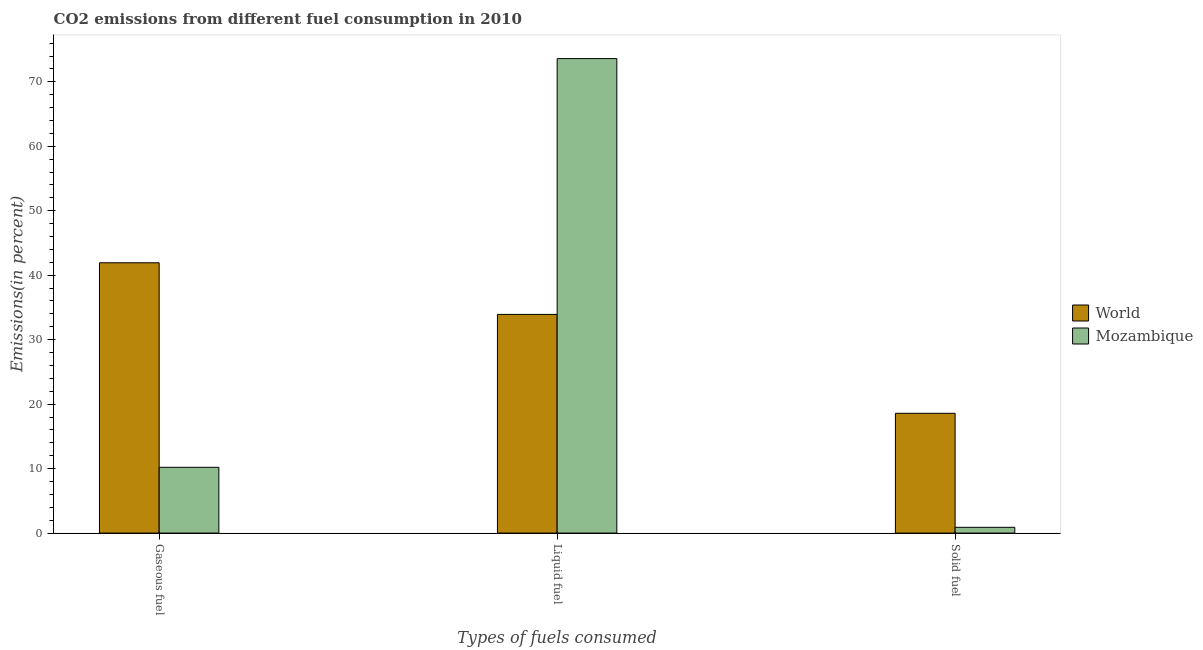Are the number of bars on each tick of the X-axis equal?
Give a very brief answer. Yes. How many bars are there on the 2nd tick from the right?
Keep it short and to the point. 2. What is the label of the 1st group of bars from the left?
Give a very brief answer. Gaseous fuel. What is the percentage of liquid fuel emission in Mozambique?
Keep it short and to the point. 73.6. Across all countries, what is the maximum percentage of liquid fuel emission?
Offer a very short reply. 73.6. Across all countries, what is the minimum percentage of liquid fuel emission?
Offer a very short reply. 33.92. What is the total percentage of gaseous fuel emission in the graph?
Offer a terse response. 52.13. What is the difference between the percentage of gaseous fuel emission in Mozambique and that in World?
Offer a terse response. -31.72. What is the difference between the percentage of solid fuel emission in Mozambique and the percentage of gaseous fuel emission in World?
Ensure brevity in your answer.  -41.03. What is the average percentage of solid fuel emission per country?
Provide a short and direct response. 9.74. What is the difference between the percentage of gaseous fuel emission and percentage of solid fuel emission in World?
Your response must be concise. 23.35. What is the ratio of the percentage of gaseous fuel emission in Mozambique to that in World?
Offer a terse response. 0.24. Is the percentage of gaseous fuel emission in Mozambique less than that in World?
Your answer should be very brief. Yes. What is the difference between the highest and the second highest percentage of solid fuel emission?
Provide a succinct answer. 17.68. What is the difference between the highest and the lowest percentage of liquid fuel emission?
Give a very brief answer. 39.68. In how many countries, is the percentage of gaseous fuel emission greater than the average percentage of gaseous fuel emission taken over all countries?
Ensure brevity in your answer.  1. What does the 1st bar from the right in Gaseous fuel represents?
Make the answer very short. Mozambique. Is it the case that in every country, the sum of the percentage of gaseous fuel emission and percentage of liquid fuel emission is greater than the percentage of solid fuel emission?
Offer a very short reply. Yes. How many bars are there?
Ensure brevity in your answer.  6. Are all the bars in the graph horizontal?
Give a very brief answer. No. How many countries are there in the graph?
Make the answer very short. 2. What is the difference between two consecutive major ticks on the Y-axis?
Your response must be concise. 10. How are the legend labels stacked?
Give a very brief answer. Vertical. What is the title of the graph?
Keep it short and to the point. CO2 emissions from different fuel consumption in 2010. What is the label or title of the X-axis?
Offer a terse response. Types of fuels consumed. What is the label or title of the Y-axis?
Provide a succinct answer. Emissions(in percent). What is the Emissions(in percent) in World in Gaseous fuel?
Provide a succinct answer. 41.93. What is the Emissions(in percent) of Mozambique in Gaseous fuel?
Your response must be concise. 10.2. What is the Emissions(in percent) of World in Liquid fuel?
Provide a succinct answer. 33.92. What is the Emissions(in percent) in Mozambique in Liquid fuel?
Your answer should be compact. 73.6. What is the Emissions(in percent) of World in Solid fuel?
Provide a succinct answer. 18.58. What is the Emissions(in percent) of Mozambique in Solid fuel?
Provide a short and direct response. 0.89. Across all Types of fuels consumed, what is the maximum Emissions(in percent) of World?
Your answer should be very brief. 41.93. Across all Types of fuels consumed, what is the maximum Emissions(in percent) of Mozambique?
Provide a short and direct response. 73.6. Across all Types of fuels consumed, what is the minimum Emissions(in percent) in World?
Keep it short and to the point. 18.58. Across all Types of fuels consumed, what is the minimum Emissions(in percent) in Mozambique?
Give a very brief answer. 0.89. What is the total Emissions(in percent) in World in the graph?
Give a very brief answer. 94.42. What is the total Emissions(in percent) in Mozambique in the graph?
Provide a succinct answer. 84.69. What is the difference between the Emissions(in percent) in World in Gaseous fuel and that in Liquid fuel?
Offer a very short reply. 8.01. What is the difference between the Emissions(in percent) in Mozambique in Gaseous fuel and that in Liquid fuel?
Provide a short and direct response. -63.39. What is the difference between the Emissions(in percent) in World in Gaseous fuel and that in Solid fuel?
Provide a short and direct response. 23.35. What is the difference between the Emissions(in percent) in Mozambique in Gaseous fuel and that in Solid fuel?
Provide a short and direct response. 9.31. What is the difference between the Emissions(in percent) of World in Liquid fuel and that in Solid fuel?
Offer a very short reply. 15.34. What is the difference between the Emissions(in percent) in Mozambique in Liquid fuel and that in Solid fuel?
Offer a terse response. 72.7. What is the difference between the Emissions(in percent) in World in Gaseous fuel and the Emissions(in percent) in Mozambique in Liquid fuel?
Offer a terse response. -31.67. What is the difference between the Emissions(in percent) of World in Gaseous fuel and the Emissions(in percent) of Mozambique in Solid fuel?
Offer a very short reply. 41.03. What is the difference between the Emissions(in percent) of World in Liquid fuel and the Emissions(in percent) of Mozambique in Solid fuel?
Offer a very short reply. 33.02. What is the average Emissions(in percent) of World per Types of fuels consumed?
Keep it short and to the point. 31.47. What is the average Emissions(in percent) of Mozambique per Types of fuels consumed?
Your response must be concise. 28.23. What is the difference between the Emissions(in percent) of World and Emissions(in percent) of Mozambique in Gaseous fuel?
Keep it short and to the point. 31.72. What is the difference between the Emissions(in percent) of World and Emissions(in percent) of Mozambique in Liquid fuel?
Provide a succinct answer. -39.68. What is the difference between the Emissions(in percent) in World and Emissions(in percent) in Mozambique in Solid fuel?
Offer a very short reply. 17.68. What is the ratio of the Emissions(in percent) in World in Gaseous fuel to that in Liquid fuel?
Offer a very short reply. 1.24. What is the ratio of the Emissions(in percent) in Mozambique in Gaseous fuel to that in Liquid fuel?
Keep it short and to the point. 0.14. What is the ratio of the Emissions(in percent) of World in Gaseous fuel to that in Solid fuel?
Keep it short and to the point. 2.26. What is the ratio of the Emissions(in percent) in Mozambique in Gaseous fuel to that in Solid fuel?
Provide a short and direct response. 11.43. What is the ratio of the Emissions(in percent) in World in Liquid fuel to that in Solid fuel?
Provide a succinct answer. 1.83. What is the ratio of the Emissions(in percent) in Mozambique in Liquid fuel to that in Solid fuel?
Provide a short and direct response. 82.43. What is the difference between the highest and the second highest Emissions(in percent) in World?
Keep it short and to the point. 8.01. What is the difference between the highest and the second highest Emissions(in percent) of Mozambique?
Give a very brief answer. 63.39. What is the difference between the highest and the lowest Emissions(in percent) in World?
Your answer should be very brief. 23.35. What is the difference between the highest and the lowest Emissions(in percent) in Mozambique?
Your response must be concise. 72.7. 